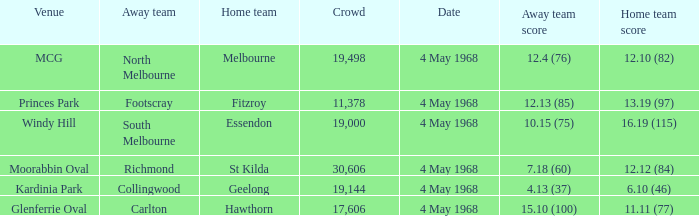Help me parse the entirety of this table. {'header': ['Venue', 'Away team', 'Home team', 'Crowd', 'Date', 'Away team score', 'Home team score'], 'rows': [['MCG', 'North Melbourne', 'Melbourne', '19,498', '4 May 1968', '12.4 (76)', '12.10 (82)'], ['Princes Park', 'Footscray', 'Fitzroy', '11,378', '4 May 1968', '12.13 (85)', '13.19 (97)'], ['Windy Hill', 'South Melbourne', 'Essendon', '19,000', '4 May 1968', '10.15 (75)', '16.19 (115)'], ['Moorabbin Oval', 'Richmond', 'St Kilda', '30,606', '4 May 1968', '7.18 (60)', '12.12 (84)'], ['Kardinia Park', 'Collingwood', 'Geelong', '19,144', '4 May 1968', '4.13 (37)', '6.10 (46)'], ['Glenferrie Oval', 'Carlton', 'Hawthorn', '17,606', '4 May 1968', '15.10 (100)', '11.11 (77)']]} How big was the crowd of the team that scored 4.13 (37)? 19144.0. 